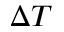Convert formula to latex. <formula><loc_0><loc_0><loc_500><loc_500>\Delta T</formula> 